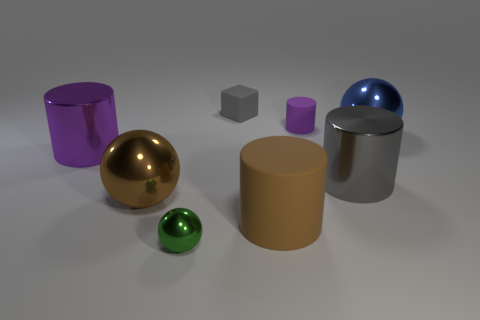There is a big metallic cylinder to the left of the green metal thing; is its color the same as the matte cylinder behind the large gray cylinder?
Your answer should be compact. Yes. What is the material of the purple thing that is the same size as the gray rubber thing?
Provide a short and direct response. Rubber. Are there any green spheres that have the same size as the gray cylinder?
Provide a short and direct response. No. Is the number of big balls that are in front of the gray cylinder less than the number of metallic blocks?
Your answer should be compact. No. Is the number of metal cylinders that are right of the green ball less than the number of big spheres that are to the right of the tiny matte cube?
Make the answer very short. No. What number of cylinders are either purple metallic objects or brown rubber things?
Offer a very short reply. 2. Do the gray object in front of the blue sphere and the large cylinder in front of the large gray thing have the same material?
Make the answer very short. No. What is the shape of the gray metal thing that is the same size as the blue shiny ball?
Offer a terse response. Cylinder. What number of other things are there of the same color as the small matte cylinder?
Provide a succinct answer. 1. How many blue things are either small cubes or rubber cylinders?
Make the answer very short. 0. 